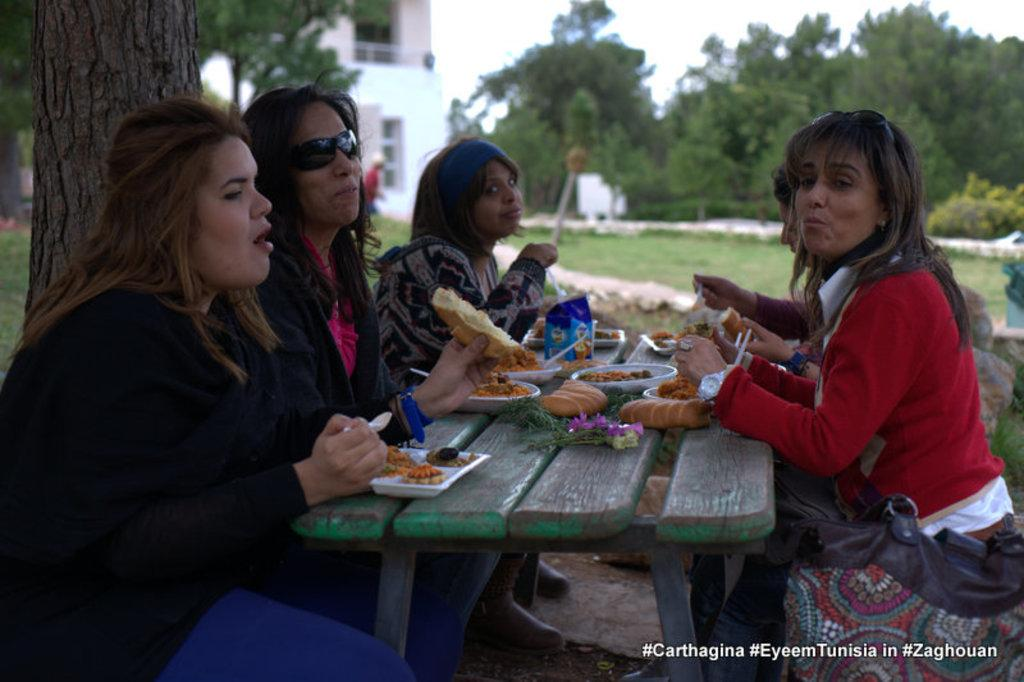How many women are in the image? There is a group of five women in the image. What are the women doing in the image? The women are sitting at a table and having food. Where is the table located in relation to the tree? The table is located near a tree. What can be seen in the background of the image? There are trees and at least one building in the background of the image. Can you tell me how many horses are tied to the tree in the image? There are no horses present in the image; it features a group of women sitting at a table near a tree. What type of tin is being used by the women to eat their food? There is no tin visible in the image; the women are likely using plates or bowls to eat their food. 